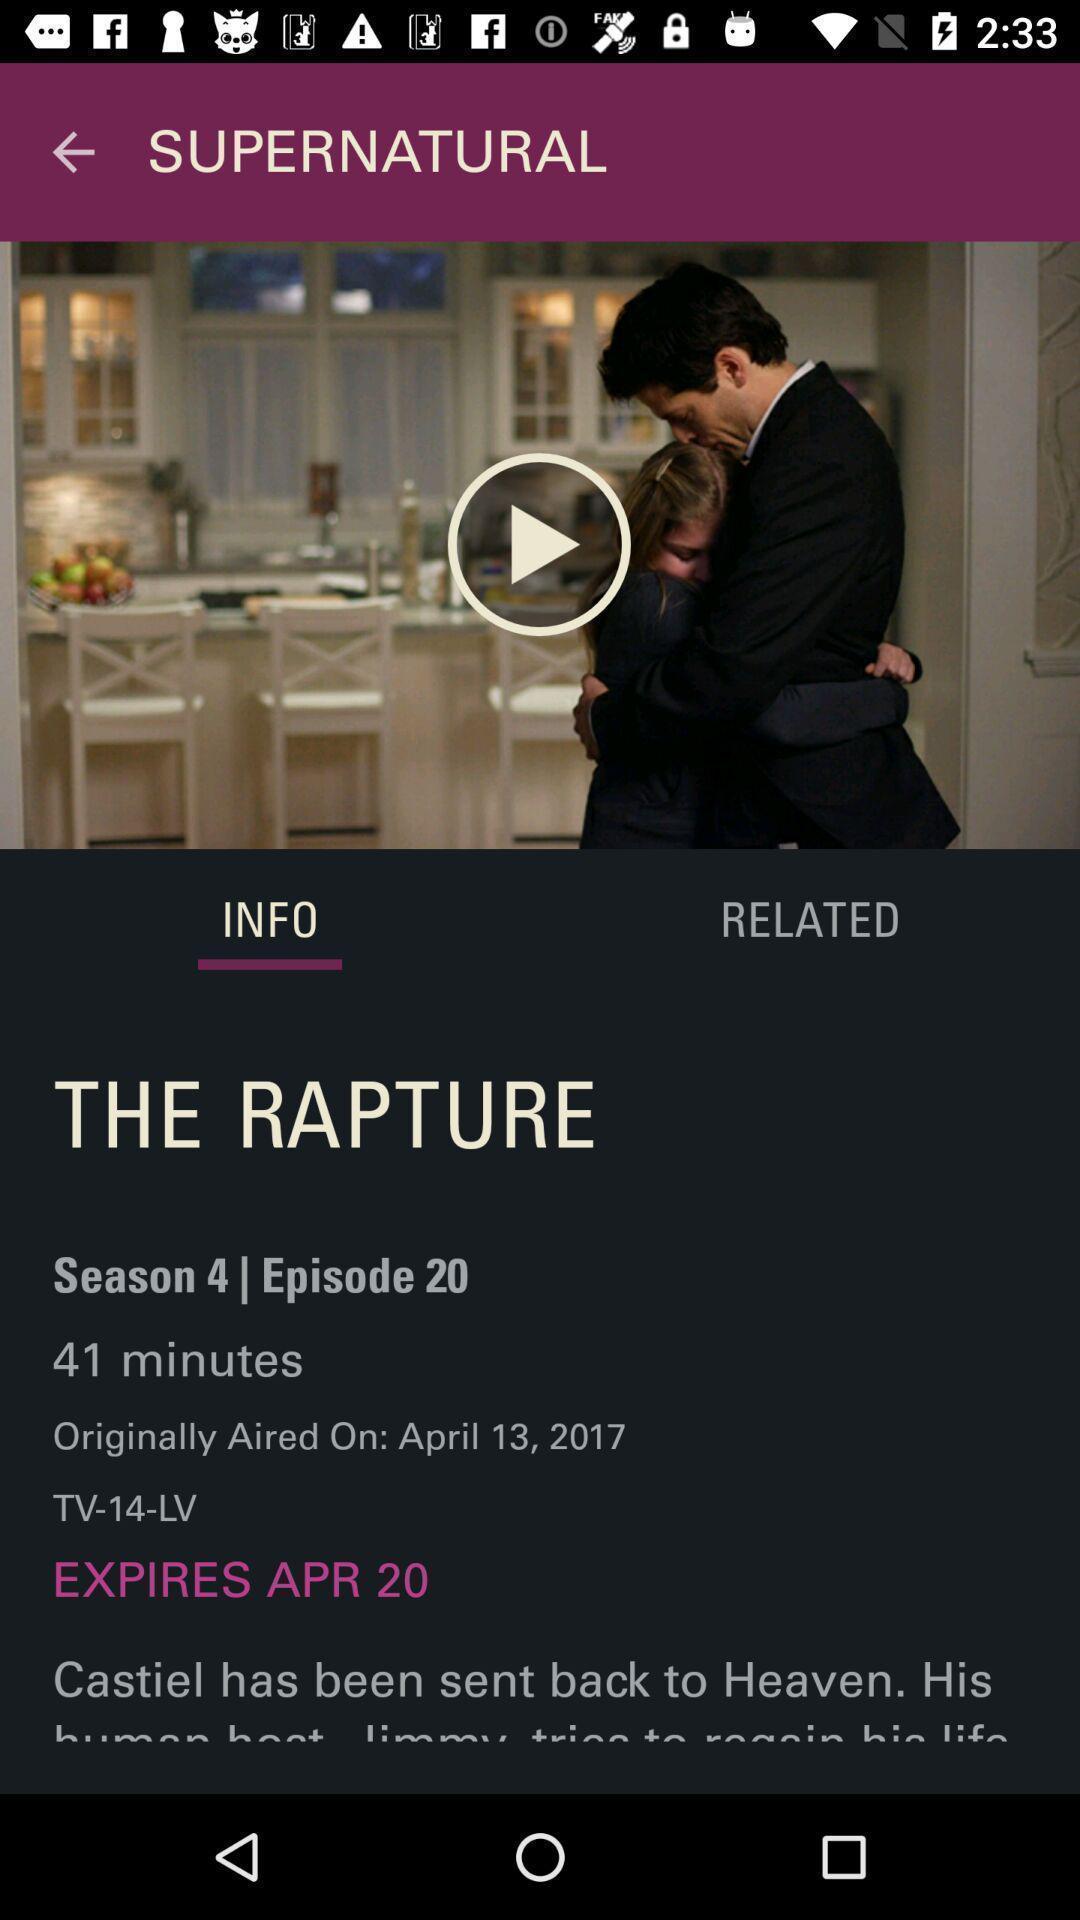Tell me what you see in this picture. Page showing details of a movie. 